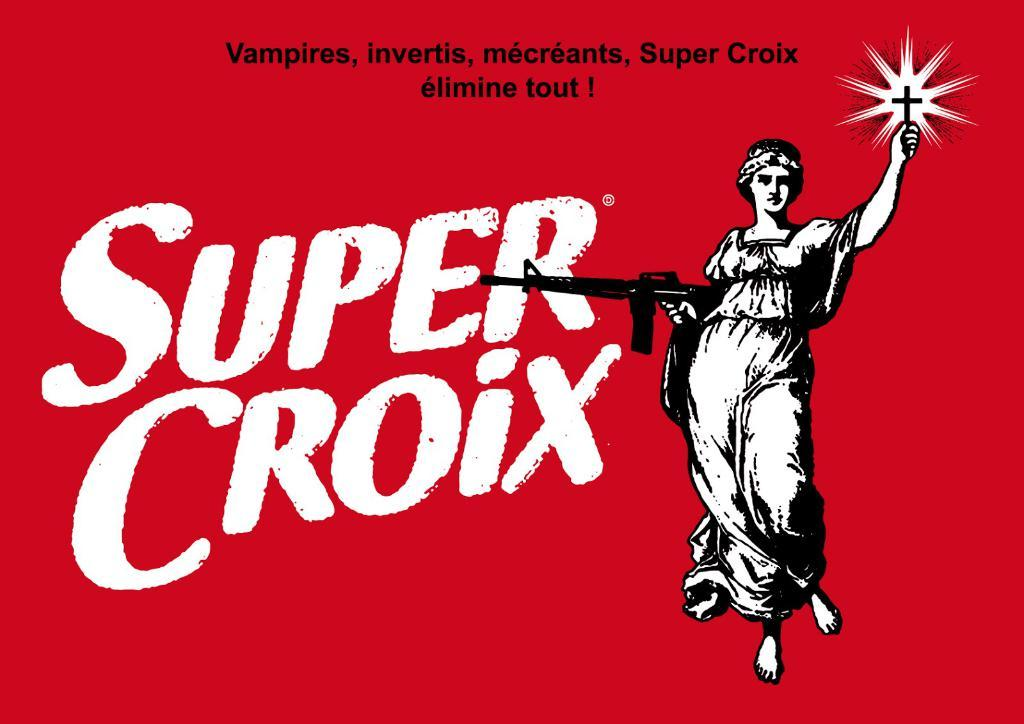What is the color of the poster in the image? The poster in the image is red. What text is written on the poster? The poster has the text "super croix" on it. What image is depicted on the poster? There is an image of a woman on the poster. What is the woman holding in the image? The woman is standing and holding a gun and a cross in the other hand. What type of string is attached to the flag in the image? There is no flag present in the image, so there is no string attached to it. How does the woman swim in the image? The image does not depict the woman swimming; she is standing and holding a gun and a cross. 